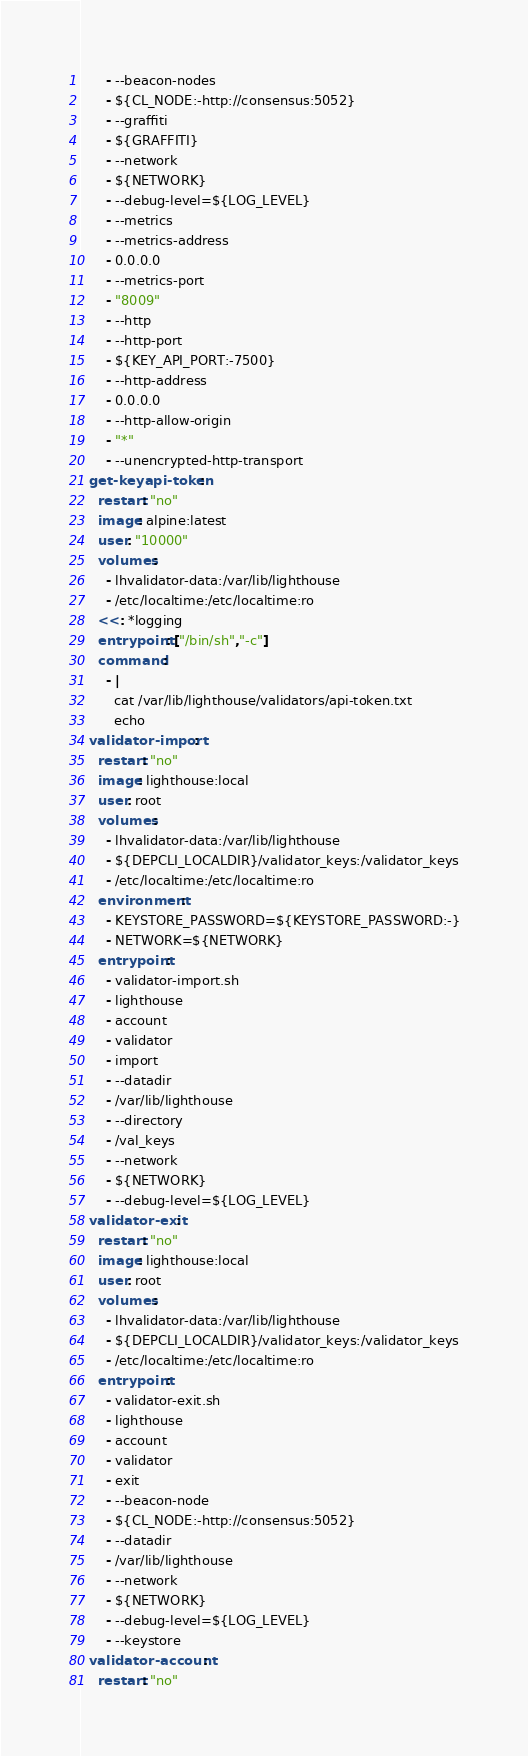<code> <loc_0><loc_0><loc_500><loc_500><_YAML_>      - --beacon-nodes
      - ${CL_NODE:-http://consensus:5052}
      - --graffiti
      - ${GRAFFITI}
      - --network
      - ${NETWORK}
      - --debug-level=${LOG_LEVEL}
      - --metrics
      - --metrics-address
      - 0.0.0.0
      - --metrics-port
      - "8009"
      - --http
      - --http-port
      - ${KEY_API_PORT:-7500}
      - --http-address
      - 0.0.0.0
      - --http-allow-origin
      - "*"
      - --unencrypted-http-transport
  get-keyapi-token:
    restart: "no"
    image: alpine:latest
    user: "10000"
    volumes:
      - lhvalidator-data:/var/lib/lighthouse
      - /etc/localtime:/etc/localtime:ro
    <<: *logging
    entrypoint: ["/bin/sh","-c"]
    command:
      - |
        cat /var/lib/lighthouse/validators/api-token.txt
        echo
  validator-import:
    restart: "no"
    image: lighthouse:local
    user: root
    volumes:
      - lhvalidator-data:/var/lib/lighthouse
      - ${DEPCLI_LOCALDIR}/validator_keys:/validator_keys
      - /etc/localtime:/etc/localtime:ro
    environment:
      - KEYSTORE_PASSWORD=${KEYSTORE_PASSWORD:-}
      - NETWORK=${NETWORK}
    entrypoint:
      - validator-import.sh
      - lighthouse
      - account
      - validator
      - import
      - --datadir
      - /var/lib/lighthouse
      - --directory
      - /val_keys
      - --network
      - ${NETWORK}
      - --debug-level=${LOG_LEVEL}
  validator-exit:
    restart: "no"
    image: lighthouse:local
    user: root
    volumes:
      - lhvalidator-data:/var/lib/lighthouse
      - ${DEPCLI_LOCALDIR}/validator_keys:/validator_keys
      - /etc/localtime:/etc/localtime:ro
    entrypoint:
      - validator-exit.sh
      - lighthouse
      - account
      - validator
      - exit
      - --beacon-node
      - ${CL_NODE:-http://consensus:5052}
      - --datadir
      - /var/lib/lighthouse
      - --network
      - ${NETWORK}
      - --debug-level=${LOG_LEVEL}
      - --keystore
  validator-account:
    restart: "no"</code> 